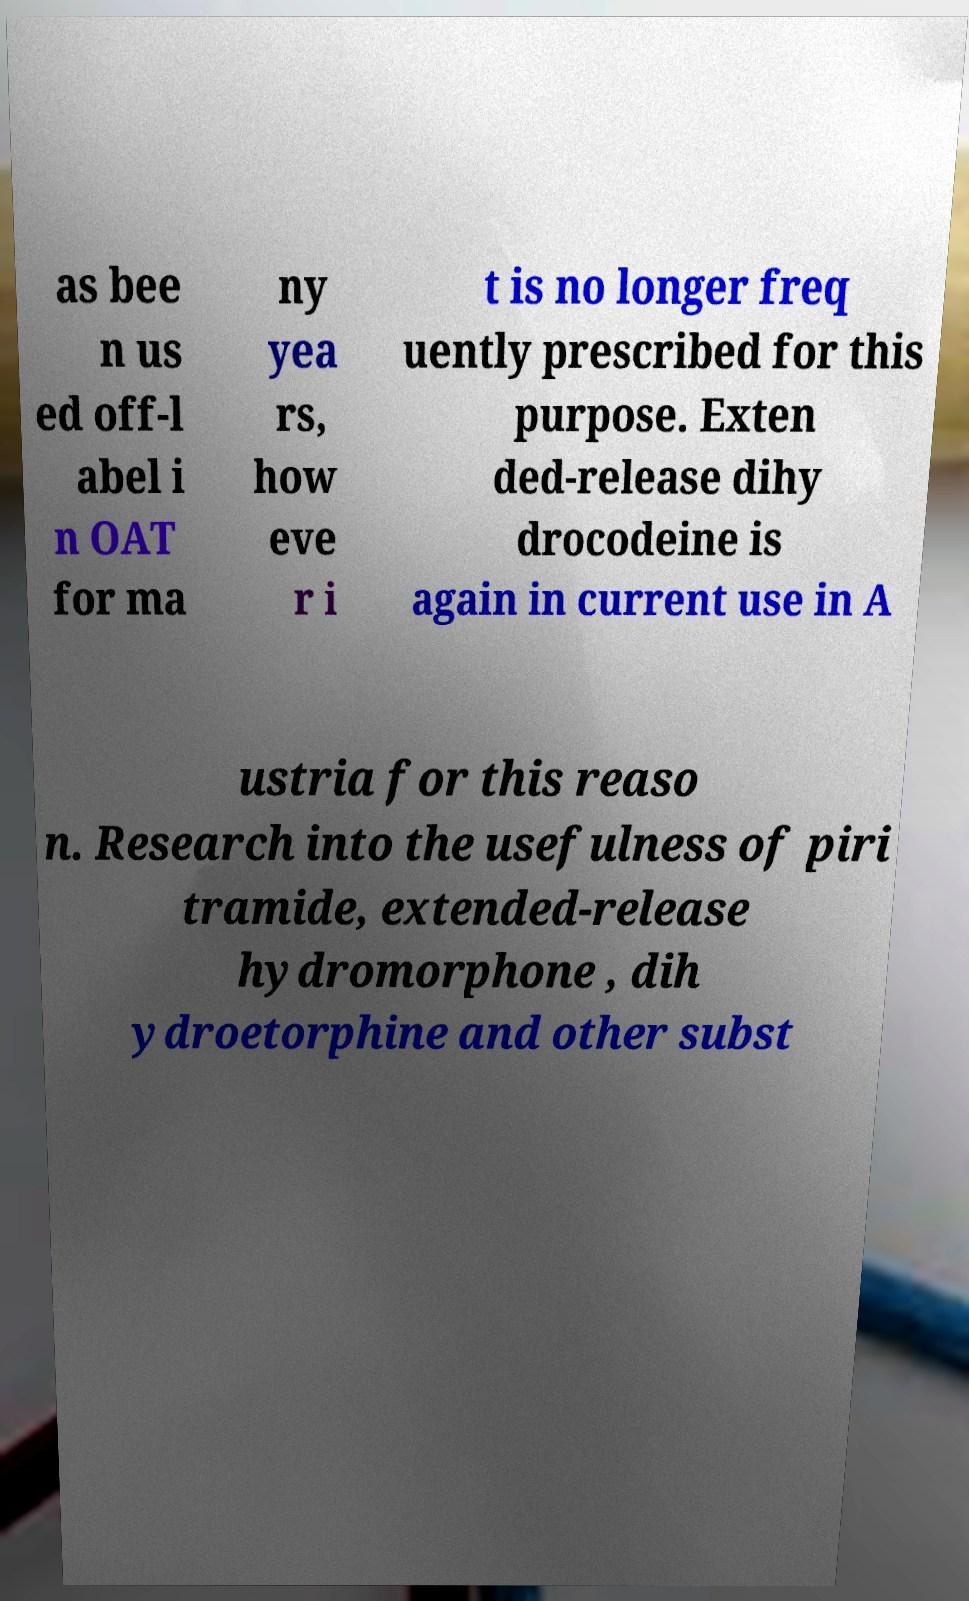Can you read and provide the text displayed in the image?This photo seems to have some interesting text. Can you extract and type it out for me? as bee n us ed off-l abel i n OAT for ma ny yea rs, how eve r i t is no longer freq uently prescribed for this purpose. Exten ded-release dihy drocodeine is again in current use in A ustria for this reaso n. Research into the usefulness of piri tramide, extended-release hydromorphone , dih ydroetorphine and other subst 